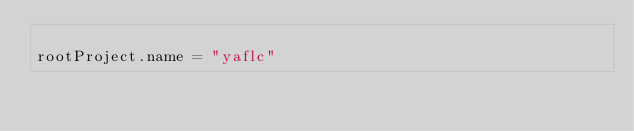Convert code to text. <code><loc_0><loc_0><loc_500><loc_500><_Kotlin_>
rootProject.name = "yaflc"

</code> 